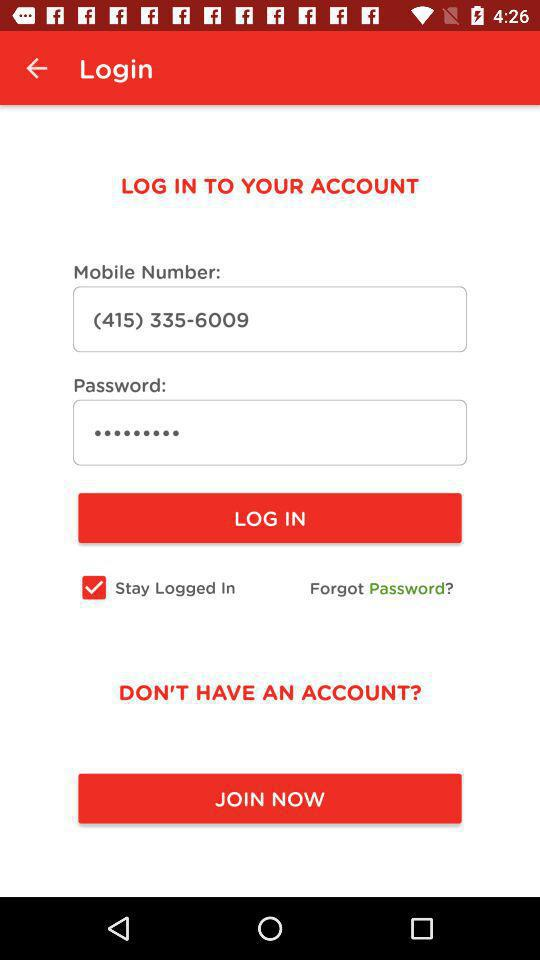What is the mobile number? The mobile number is (415) 335-6009. 